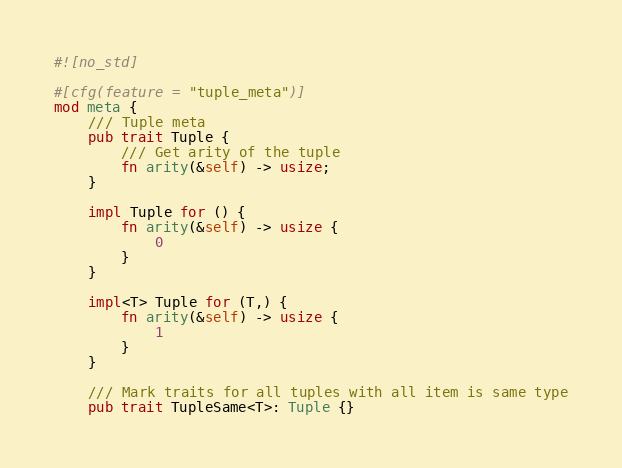<code> <loc_0><loc_0><loc_500><loc_500><_Rust_>#![no_std]

#[cfg(feature = "tuple_meta")]
mod meta {
    /// Tuple meta
    pub trait Tuple {
        /// Get arity of the tuple
        fn arity(&self) -> usize;
    }

    impl Tuple for () {
        fn arity(&self) -> usize {
            0
        }
    }

    impl<T> Tuple for (T,) {
        fn arity(&self) -> usize {
            1
        }
    }

    /// Mark traits for all tuples with all item is same type
    pub trait TupleSame<T>: Tuple {}
</code> 